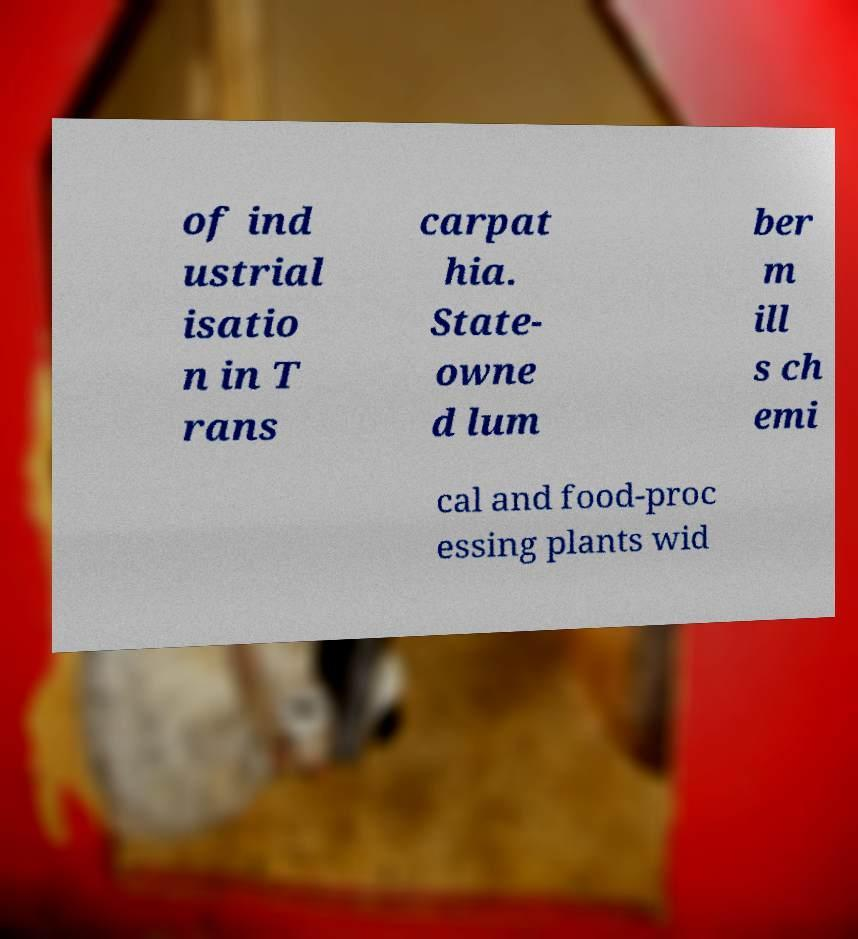For documentation purposes, I need the text within this image transcribed. Could you provide that? of ind ustrial isatio n in T rans carpat hia. State- owne d lum ber m ill s ch emi cal and food-proc essing plants wid 